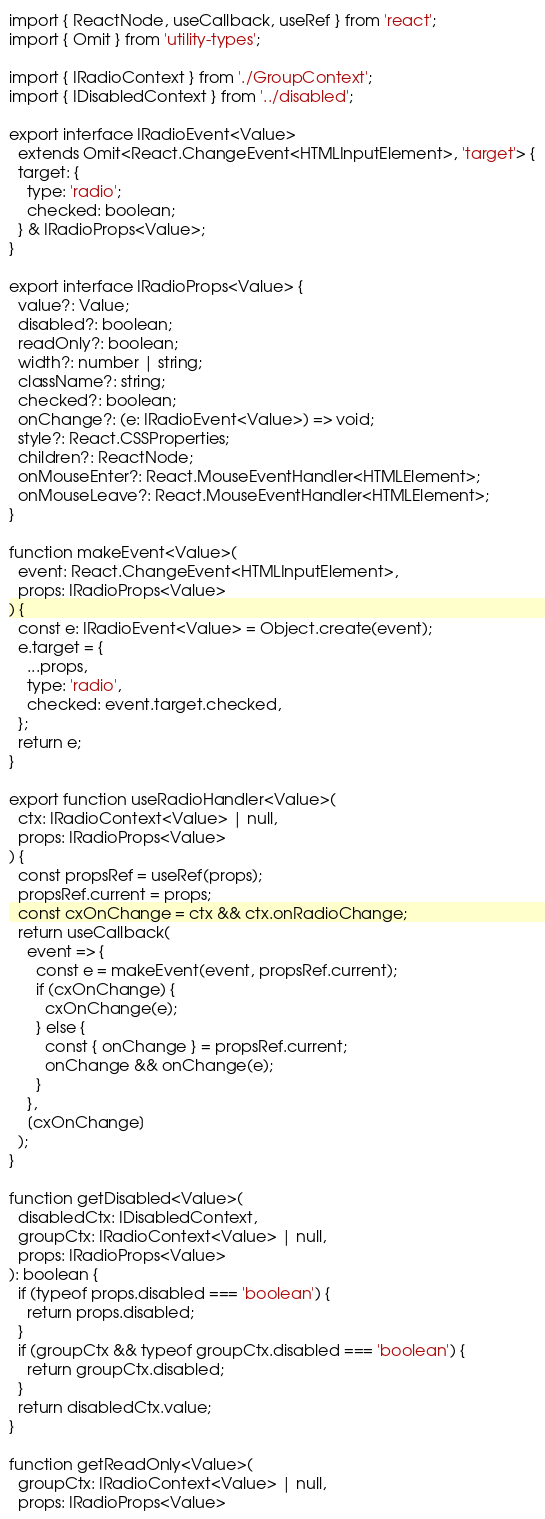<code> <loc_0><loc_0><loc_500><loc_500><_TypeScript_>import { ReactNode, useCallback, useRef } from 'react';
import { Omit } from 'utility-types';

import { IRadioContext } from './GroupContext';
import { IDisabledContext } from '../disabled';

export interface IRadioEvent<Value>
  extends Omit<React.ChangeEvent<HTMLInputElement>, 'target'> {
  target: {
    type: 'radio';
    checked: boolean;
  } & IRadioProps<Value>;
}

export interface IRadioProps<Value> {
  value?: Value;
  disabled?: boolean;
  readOnly?: boolean;
  width?: number | string;
  className?: string;
  checked?: boolean;
  onChange?: (e: IRadioEvent<Value>) => void;
  style?: React.CSSProperties;
  children?: ReactNode;
  onMouseEnter?: React.MouseEventHandler<HTMLElement>;
  onMouseLeave?: React.MouseEventHandler<HTMLElement>;
}

function makeEvent<Value>(
  event: React.ChangeEvent<HTMLInputElement>,
  props: IRadioProps<Value>
) {
  const e: IRadioEvent<Value> = Object.create(event);
  e.target = {
    ...props,
    type: 'radio',
    checked: event.target.checked,
  };
  return e;
}

export function useRadioHandler<Value>(
  ctx: IRadioContext<Value> | null,
  props: IRadioProps<Value>
) {
  const propsRef = useRef(props);
  propsRef.current = props;
  const cxOnChange = ctx && ctx.onRadioChange;
  return useCallback(
    event => {
      const e = makeEvent(event, propsRef.current);
      if (cxOnChange) {
        cxOnChange(e);
      } else {
        const { onChange } = propsRef.current;
        onChange && onChange(e);
      }
    },
    [cxOnChange]
  );
}

function getDisabled<Value>(
  disabledCtx: IDisabledContext,
  groupCtx: IRadioContext<Value> | null,
  props: IRadioProps<Value>
): boolean {
  if (typeof props.disabled === 'boolean') {
    return props.disabled;
  }
  if (groupCtx && typeof groupCtx.disabled === 'boolean') {
    return groupCtx.disabled;
  }
  return disabledCtx.value;
}

function getReadOnly<Value>(
  groupCtx: IRadioContext<Value> | null,
  props: IRadioProps<Value></code> 